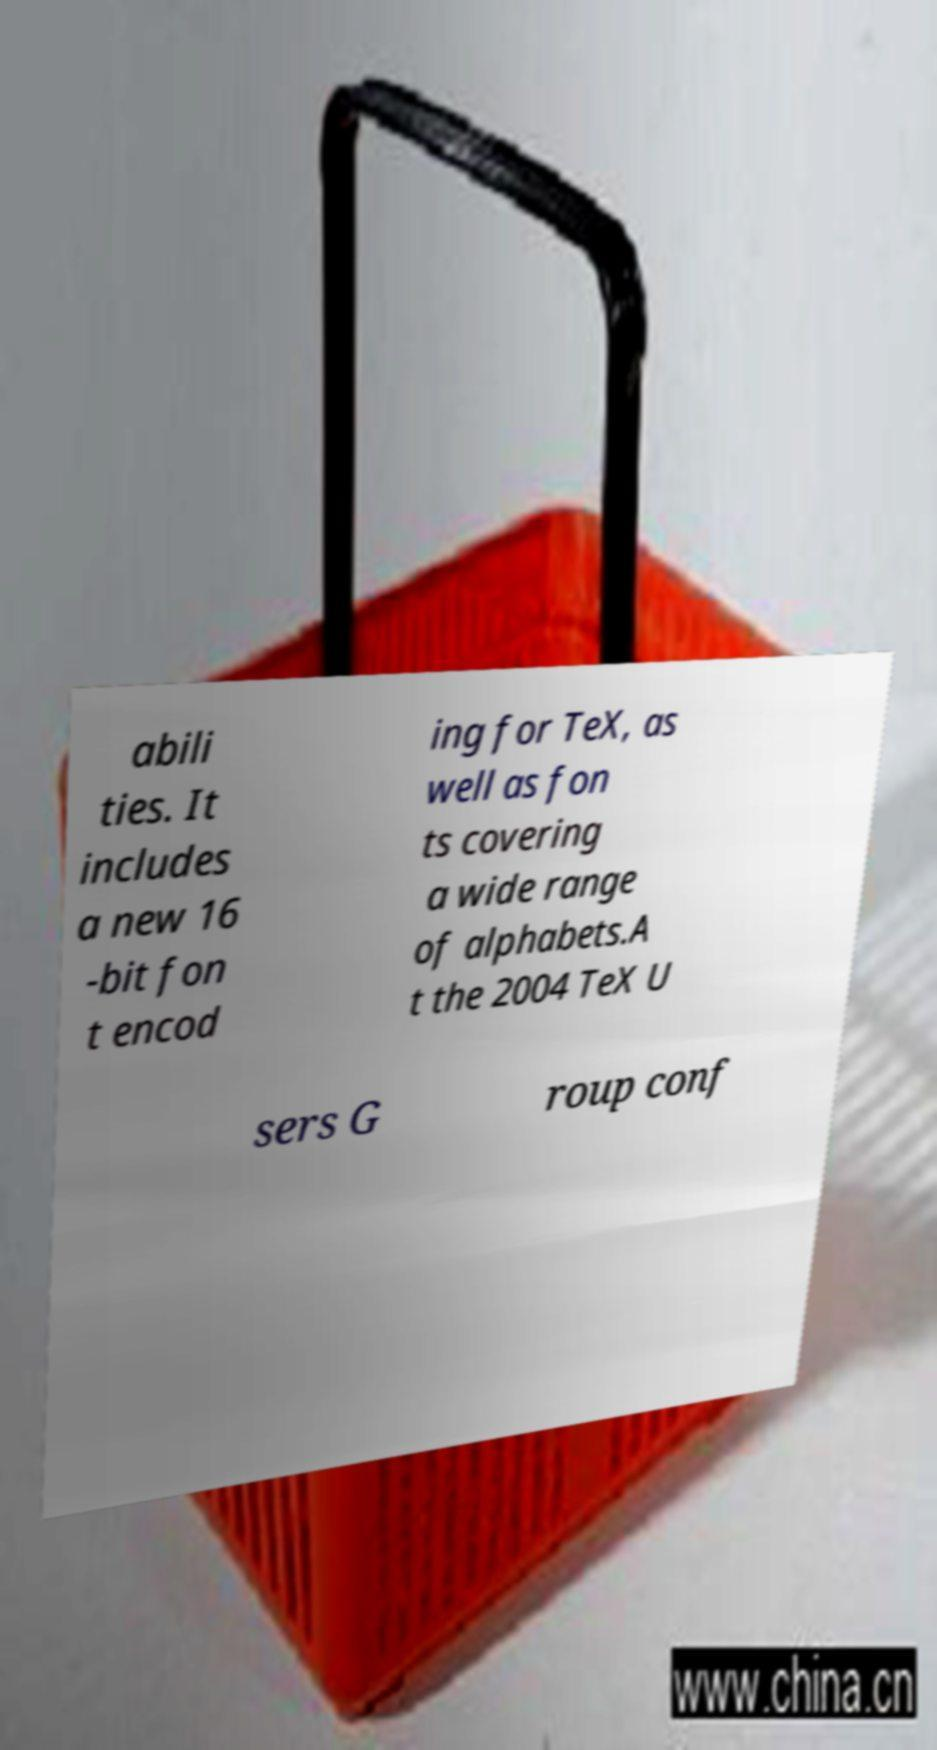Can you read and provide the text displayed in the image?This photo seems to have some interesting text. Can you extract and type it out for me? abili ties. It includes a new 16 -bit fon t encod ing for TeX, as well as fon ts covering a wide range of alphabets.A t the 2004 TeX U sers G roup conf 